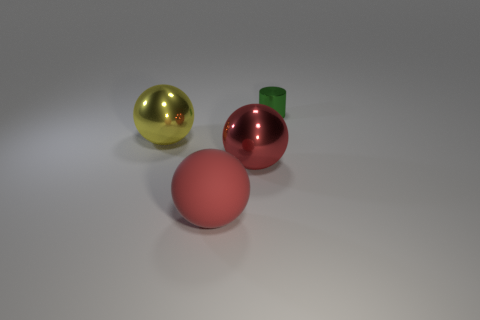Is there anything else that has the same size as the green object?
Ensure brevity in your answer.  No. What shape is the big shiny object that is the same color as the matte object?
Your answer should be very brief. Sphere. How many other matte objects are the same shape as the large yellow object?
Your response must be concise. 1. What is the size of the green cylinder that is the same material as the yellow sphere?
Give a very brief answer. Small. Is the yellow sphere the same size as the metal cylinder?
Your answer should be compact. No. Are there any small brown matte things?
Provide a succinct answer. No. There is a metal thing right of the big metal ball that is in front of the large ball on the left side of the large matte object; what size is it?
Keep it short and to the point. Small. What number of other big spheres have the same material as the yellow sphere?
Provide a succinct answer. 1. How many red balls have the same size as the yellow object?
Your answer should be very brief. 2. What material is the red thing that is in front of the big shiny ball that is on the right side of the shiny ball that is behind the red shiny ball?
Ensure brevity in your answer.  Rubber. 